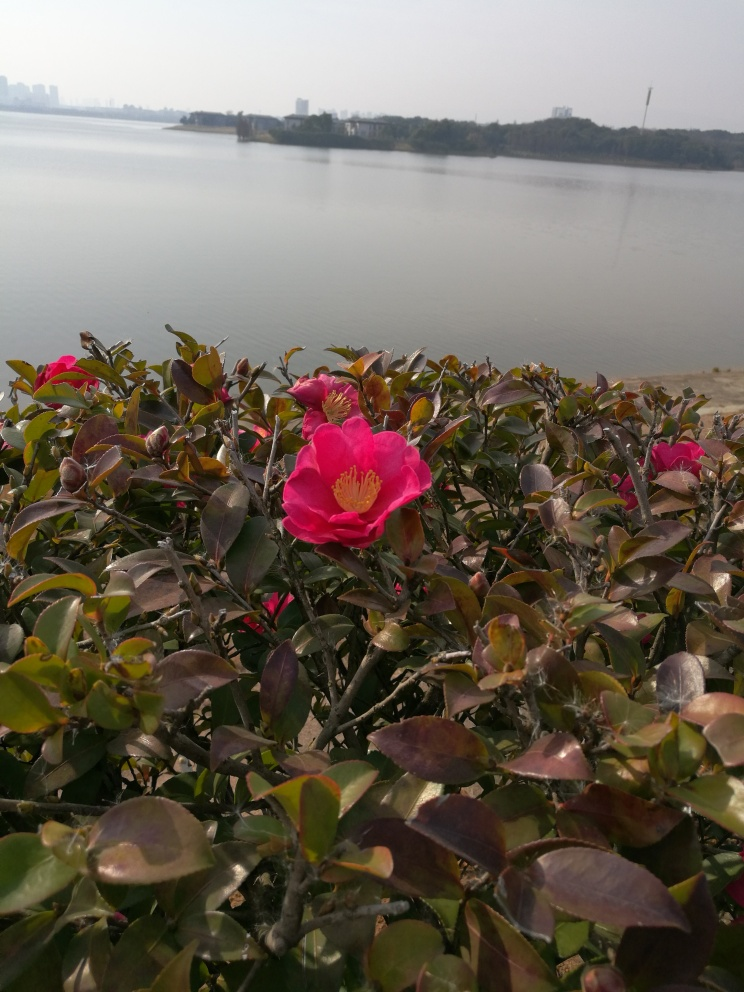What might be the significance of the location where these flowers are growing? The location appears to be lakeside, with the water body and urban structures in the distance suggesting an interface between natural and man-made environments. This juxtaposition might indicate a city park or a cultivated garden designed to provide a green oasis within an urban area. Such locations are significant as they serve as habitats for plant species and offer residents a respite from the urban landscape, promoting biodiversity and mental well-being. 